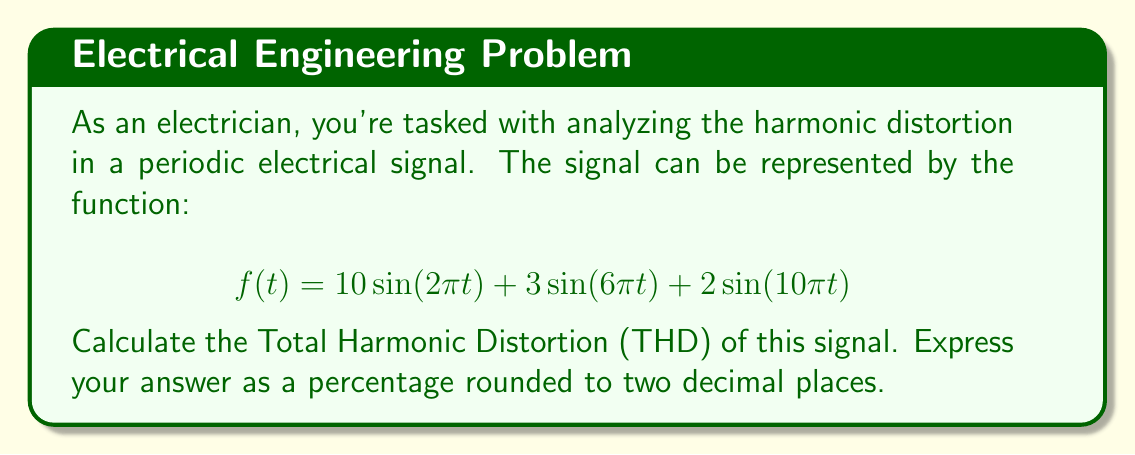Solve this math problem. To calculate the Total Harmonic Distortion (THD), we'll follow these steps:

1) Identify the fundamental frequency and harmonics:
   - Fundamental (1st harmonic): $10\sin(2\pi t)$
   - 3rd harmonic: $3\sin(6\pi t)$
   - 5th harmonic: $2\sin(10\pi t)$

2) Calculate the RMS value of each component:
   For a sinusoidal signal $A\sin(\omega t)$, the RMS value is $A/\sqrt{2}$

   - Fundamental: $A_1 = 10/\sqrt{2} = 7.071$
   - 3rd harmonic: $A_3 = 3/\sqrt{2} = 2.121$
   - 5th harmonic: $A_5 = 2/\sqrt{2} = 1.414$

3) Apply the THD formula:

   $$THD = \frac{\sqrt{\sum_{n=2}^{\infty} A_n^2}}{A_1} \times 100\%$$

   Where $A_1$ is the RMS of the fundamental and $A_n$ are the RMS values of the harmonics.

4) Substitute the values:

   $$THD = \frac{\sqrt{(2.121)^2 + (1.414)^2}}{7.071} \times 100\%$$

5) Calculate:

   $$THD = \frac{\sqrt{4.5 + 2}}{7.071} \times 100\% = \frac{\sqrt{6.5}}{7.071} \times 100\% = 36.05\%$$

6) Round to two decimal places: 36.05%
Answer: 36.05% 